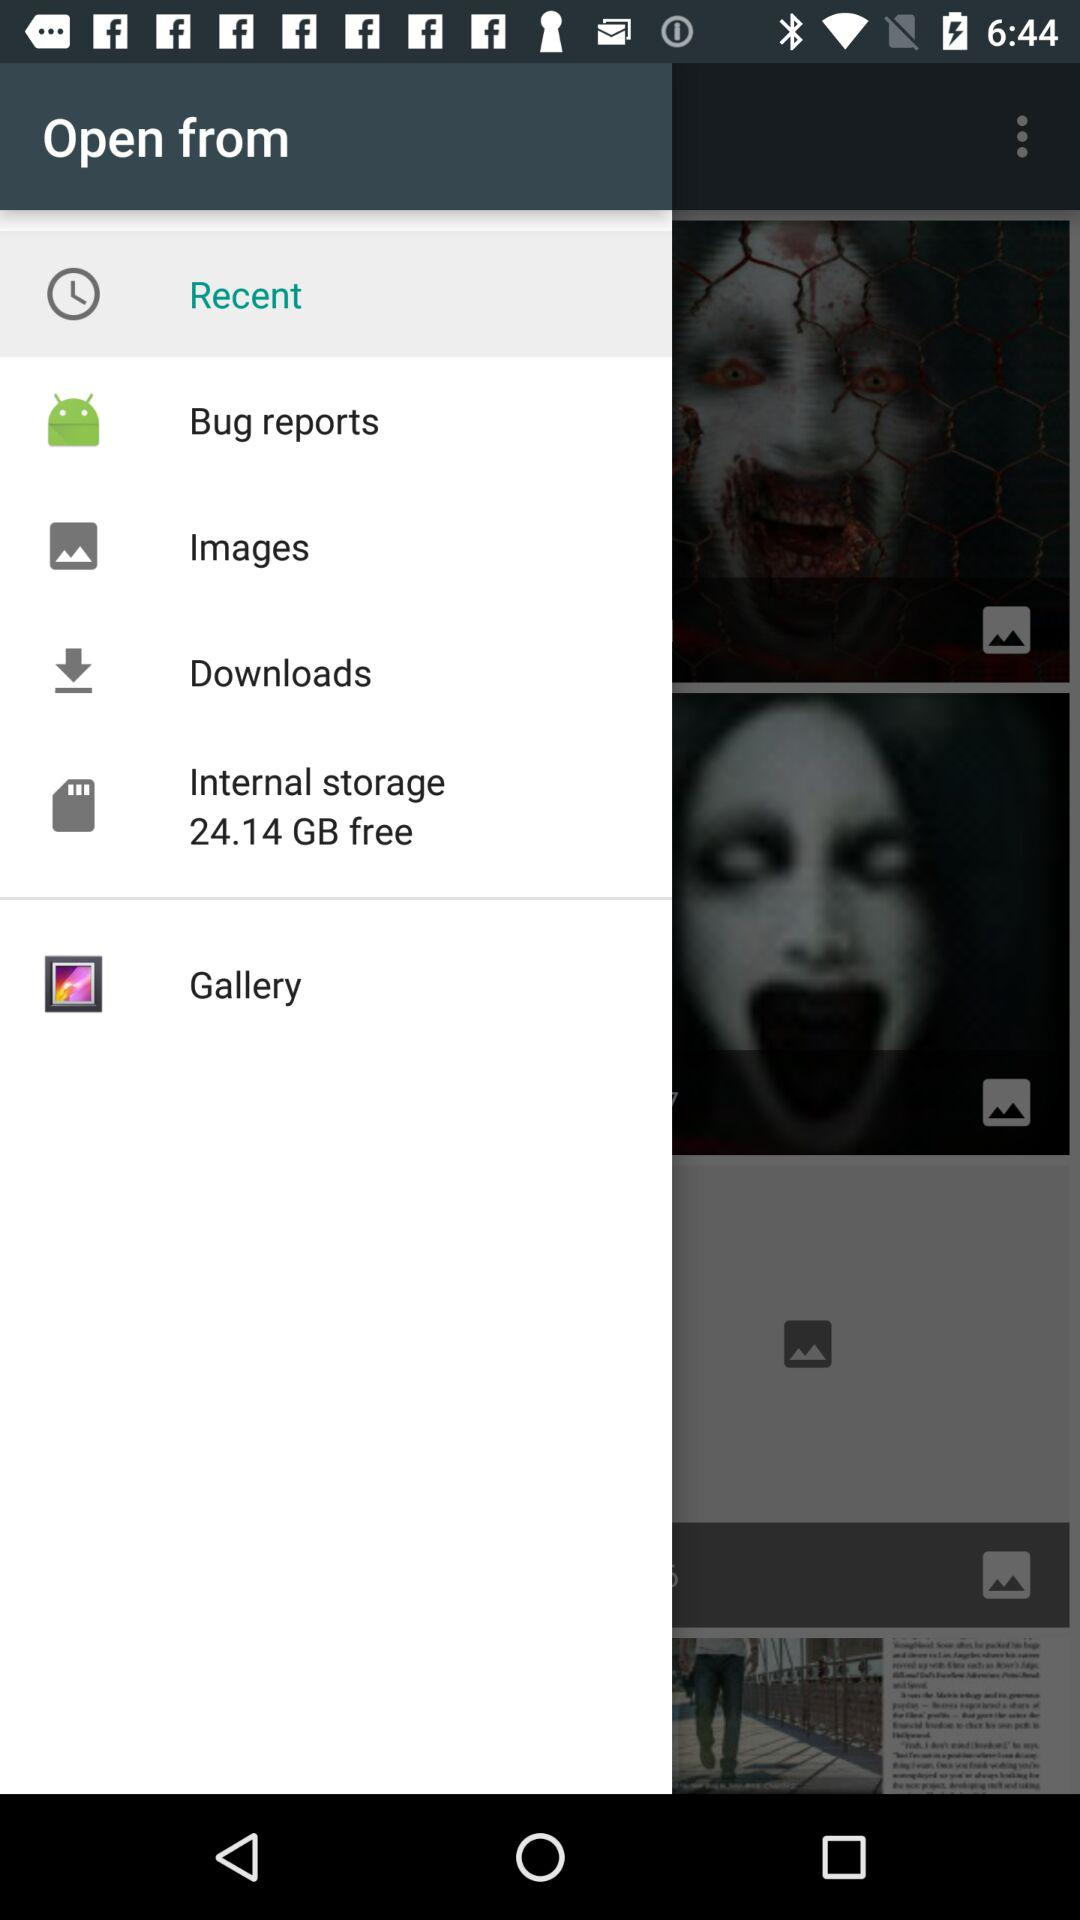What option has been chosen? The chosen option is "Recent". 